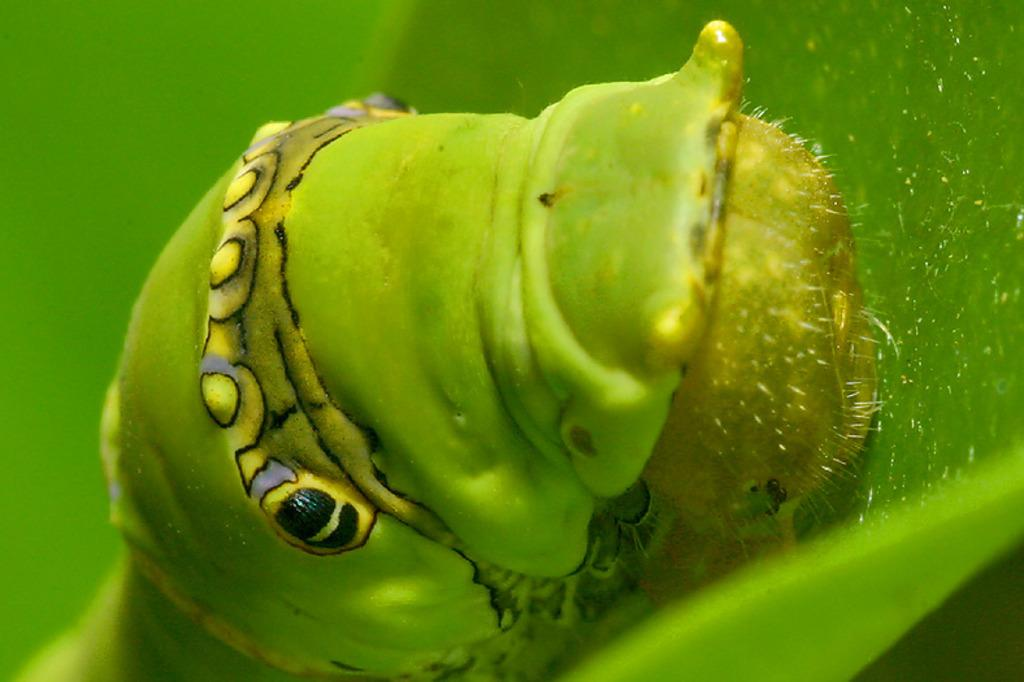What is the main subject of the image? The main subject of the image is a caterpillar. Can you describe the appearance of the caterpillar? The caterpillar is green, yellow, and black in color. Where is the caterpillar located in the image? The caterpillar is on a leaf. What color is the leaf? The leaf is green in color. What type of house is visible in the background of the image? There is no house visible in the image; it features a caterpillar on a leaf. Can you describe the arm of the caterpillar in the image? Caterpillars do not have arms; they have multiple pairs of legs. 